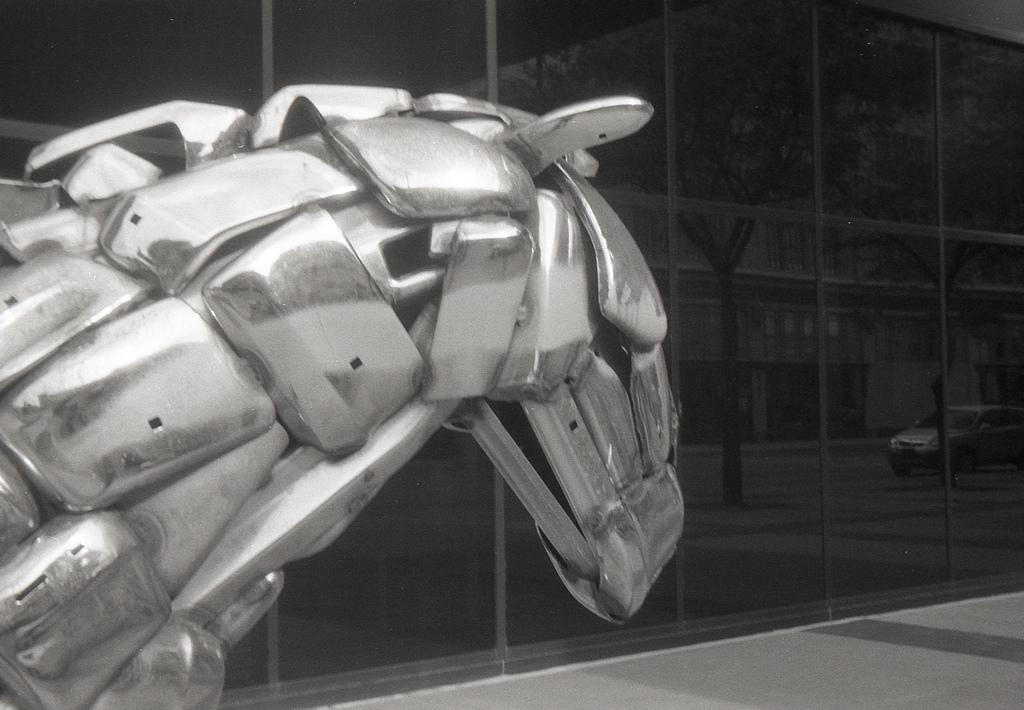What type of object is made of metal in the image? There is a metallic object in the image, but its specific nature is not mentioned in the facts. What is the material of the wall in the image? The wall in the image is made of glass. What can be seen reflected in the glass wall? The glass wall reflects a vehicle, a tree, and buildings. Can you see a police officer wearing a sock in the image? There is no mention of a police officer or a sock in the image. What type of ray is emitted from the metallic object in the image? There is no mention of any ray being emitted from the metallic object in the image. 